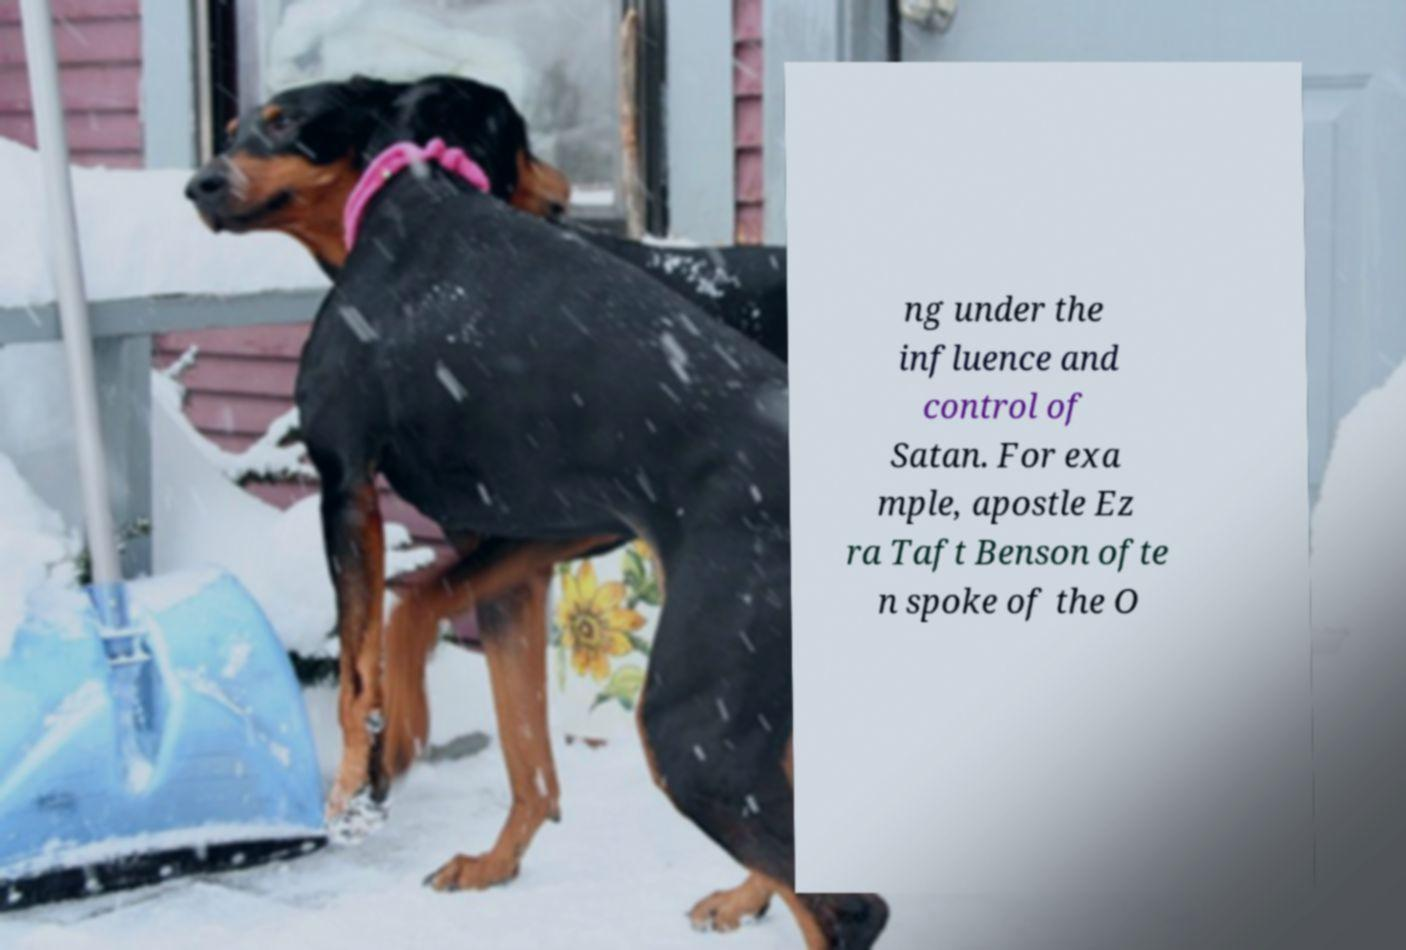Could you assist in decoding the text presented in this image and type it out clearly? ng under the influence and control of Satan. For exa mple, apostle Ez ra Taft Benson ofte n spoke of the O 